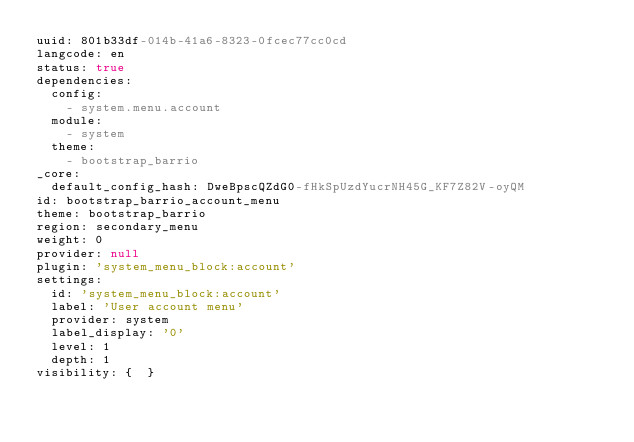<code> <loc_0><loc_0><loc_500><loc_500><_YAML_>uuid: 801b33df-014b-41a6-8323-0fcec77cc0cd
langcode: en
status: true
dependencies:
  config:
    - system.menu.account
  module:
    - system
  theme:
    - bootstrap_barrio
_core:
  default_config_hash: DweBpscQZdG0-fHkSpUzdYucrNH45G_KF7Z82V-oyQM
id: bootstrap_barrio_account_menu
theme: bootstrap_barrio
region: secondary_menu
weight: 0
provider: null
plugin: 'system_menu_block:account'
settings:
  id: 'system_menu_block:account'
  label: 'User account menu'
  provider: system
  label_display: '0'
  level: 1
  depth: 1
visibility: {  }
</code> 